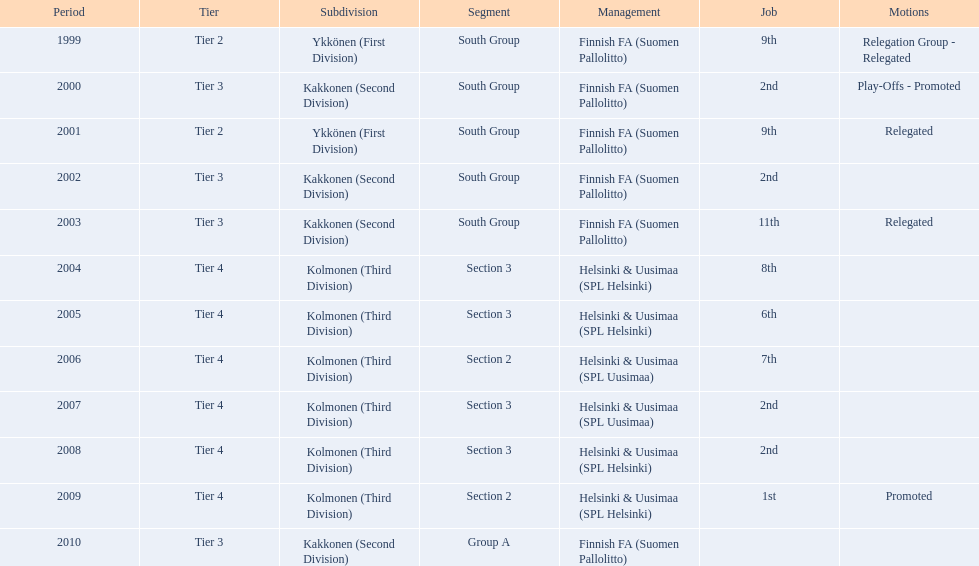What is the first tier listed? Tier 2. Parse the table in full. {'header': ['Period', 'Tier', 'Subdivision', 'Segment', 'Management', 'Job', 'Motions'], 'rows': [['1999', 'Tier 2', 'Ykkönen (First Division)', 'South Group', 'Finnish FA (Suomen Pallolitto)', '9th', 'Relegation Group - Relegated'], ['2000', 'Tier 3', 'Kakkonen (Second Division)', 'South Group', 'Finnish FA (Suomen Pallolitto)', '2nd', 'Play-Offs - Promoted'], ['2001', 'Tier 2', 'Ykkönen (First Division)', 'South Group', 'Finnish FA (Suomen Pallolitto)', '9th', 'Relegated'], ['2002', 'Tier 3', 'Kakkonen (Second Division)', 'South Group', 'Finnish FA (Suomen Pallolitto)', '2nd', ''], ['2003', 'Tier 3', 'Kakkonen (Second Division)', 'South Group', 'Finnish FA (Suomen Pallolitto)', '11th', 'Relegated'], ['2004', 'Tier 4', 'Kolmonen (Third Division)', 'Section 3', 'Helsinki & Uusimaa (SPL Helsinki)', '8th', ''], ['2005', 'Tier 4', 'Kolmonen (Third Division)', 'Section 3', 'Helsinki & Uusimaa (SPL Helsinki)', '6th', ''], ['2006', 'Tier 4', 'Kolmonen (Third Division)', 'Section 2', 'Helsinki & Uusimaa (SPL Uusimaa)', '7th', ''], ['2007', 'Tier 4', 'Kolmonen (Third Division)', 'Section 3', 'Helsinki & Uusimaa (SPL Uusimaa)', '2nd', ''], ['2008', 'Tier 4', 'Kolmonen (Third Division)', 'Section 3', 'Helsinki & Uusimaa (SPL Helsinki)', '2nd', ''], ['2009', 'Tier 4', 'Kolmonen (Third Division)', 'Section 2', 'Helsinki & Uusimaa (SPL Helsinki)', '1st', 'Promoted'], ['2010', 'Tier 3', 'Kakkonen (Second Division)', 'Group A', 'Finnish FA (Suomen Pallolitto)', '', '']]} 